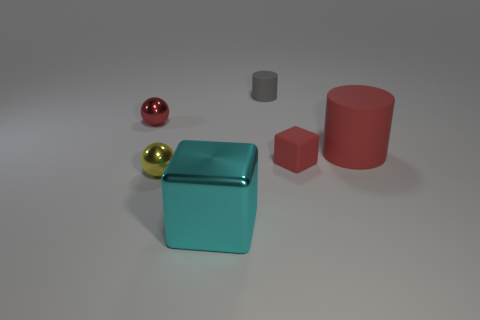Add 2 green shiny balls. How many objects exist? 8 Subtract all cylinders. How many objects are left? 4 Subtract all small balls. Subtract all big red rubber cylinders. How many objects are left? 3 Add 3 gray rubber cylinders. How many gray rubber cylinders are left? 4 Add 3 large red cylinders. How many large red cylinders exist? 4 Subtract 1 cyan cubes. How many objects are left? 5 